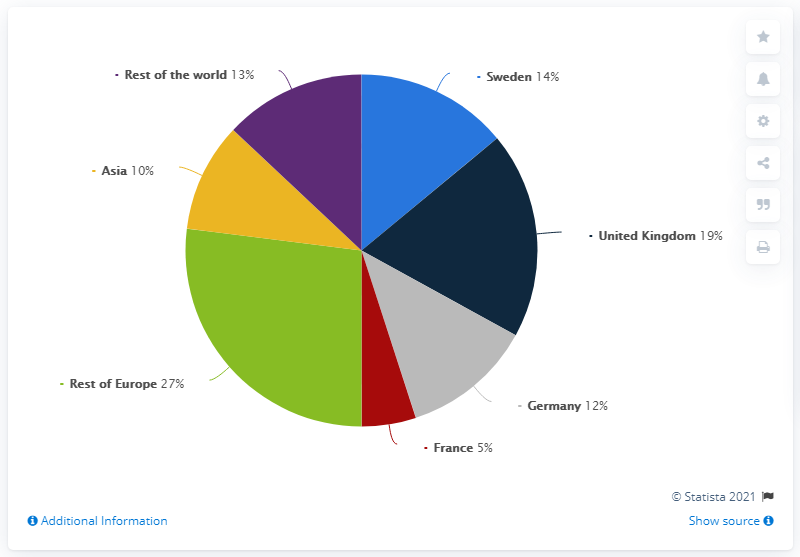Outline some significant characteristics in this image. In 2020, 19% of SCA's net sales were generated from the UK. The United Kingdom contributed the largest share of sales among all countries. The total share contributed by European countries is 77.. In 2020, approximately 19% of SCA's net sales were generated from sales to the UK. 